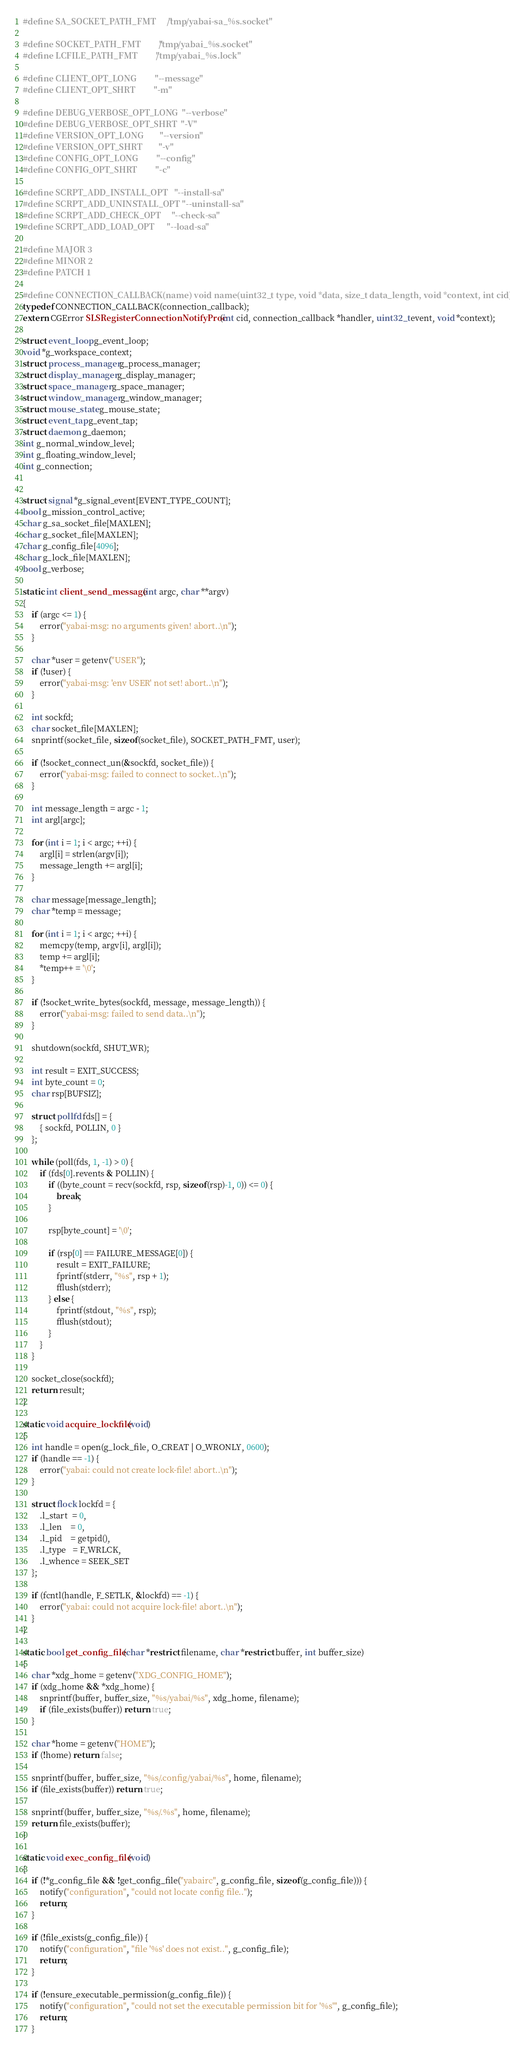<code> <loc_0><loc_0><loc_500><loc_500><_C_>#define SA_SOCKET_PATH_FMT      "/tmp/yabai-sa_%s.socket"

#define SOCKET_PATH_FMT         "/tmp/yabai_%s.socket"
#define LCFILE_PATH_FMT         "/tmp/yabai_%s.lock"

#define CLIENT_OPT_LONG         "--message"
#define CLIENT_OPT_SHRT         "-m"

#define DEBUG_VERBOSE_OPT_LONG  "--verbose"
#define DEBUG_VERBOSE_OPT_SHRT  "-V"
#define VERSION_OPT_LONG        "--version"
#define VERSION_OPT_SHRT        "-v"
#define CONFIG_OPT_LONG         "--config"
#define CONFIG_OPT_SHRT         "-c"

#define SCRPT_ADD_INSTALL_OPT   "--install-sa"
#define SCRPT_ADD_UNINSTALL_OPT "--uninstall-sa"
#define SCRPT_ADD_CHECK_OPT     "--check-sa"
#define SCRPT_ADD_LOAD_OPT      "--load-sa"

#define MAJOR 3
#define MINOR 2
#define PATCH 1

#define CONNECTION_CALLBACK(name) void name(uint32_t type, void *data, size_t data_length, void *context, int cid)
typedef CONNECTION_CALLBACK(connection_callback);
extern CGError SLSRegisterConnectionNotifyProc(int cid, connection_callback *handler, uint32_t event, void *context);

struct event_loop g_event_loop;
void *g_workspace_context;
struct process_manager g_process_manager;
struct display_manager g_display_manager;
struct space_manager g_space_manager;
struct window_manager g_window_manager;
struct mouse_state g_mouse_state;
struct event_tap g_event_tap;
struct daemon g_daemon;
int g_normal_window_level;
int g_floating_window_level;
int g_connection;


struct signal *g_signal_event[EVENT_TYPE_COUNT];
bool g_mission_control_active;
char g_sa_socket_file[MAXLEN];
char g_socket_file[MAXLEN];
char g_config_file[4096];
char g_lock_file[MAXLEN];
bool g_verbose;

static int client_send_message(int argc, char **argv)
{
    if (argc <= 1) {
        error("yabai-msg: no arguments given! abort..\n");
    }

    char *user = getenv("USER");
    if (!user) {
        error("yabai-msg: 'env USER' not set! abort..\n");
    }

    int sockfd;
    char socket_file[MAXLEN];
    snprintf(socket_file, sizeof(socket_file), SOCKET_PATH_FMT, user);

    if (!socket_connect_un(&sockfd, socket_file)) {
        error("yabai-msg: failed to connect to socket..\n");
    }

    int message_length = argc - 1;
    int argl[argc];

    for (int i = 1; i < argc; ++i) {
        argl[i] = strlen(argv[i]);
        message_length += argl[i];
    }

    char message[message_length];
    char *temp = message;

    for (int i = 1; i < argc; ++i) {
        memcpy(temp, argv[i], argl[i]);
        temp += argl[i];
        *temp++ = '\0';
    }

    if (!socket_write_bytes(sockfd, message, message_length)) {
        error("yabai-msg: failed to send data..\n");
    }

    shutdown(sockfd, SHUT_WR);

    int result = EXIT_SUCCESS;
    int byte_count = 0;
    char rsp[BUFSIZ];

    struct pollfd fds[] = {
        { sockfd, POLLIN, 0 }
    };

    while (poll(fds, 1, -1) > 0) {
        if (fds[0].revents & POLLIN) {
            if ((byte_count = recv(sockfd, rsp, sizeof(rsp)-1, 0)) <= 0) {
                break;
            }

            rsp[byte_count] = '\0';

            if (rsp[0] == FAILURE_MESSAGE[0]) {
                result = EXIT_FAILURE;
                fprintf(stderr, "%s", rsp + 1);
                fflush(stderr);
            } else {
                fprintf(stdout, "%s", rsp);
                fflush(stdout);
            }
        }
    }

    socket_close(sockfd);
    return result;
}

static void acquire_lockfile(void)
{
    int handle = open(g_lock_file, O_CREAT | O_WRONLY, 0600);
    if (handle == -1) {
        error("yabai: could not create lock-file! abort..\n");
    }

    struct flock lockfd = {
        .l_start  = 0,
        .l_len    = 0,
        .l_pid    = getpid(),
        .l_type   = F_WRLCK,
        .l_whence = SEEK_SET
    };

    if (fcntl(handle, F_SETLK, &lockfd) == -1) {
        error("yabai: could not acquire lock-file! abort..\n");
    }
}

static bool get_config_file(char *restrict filename, char *restrict buffer, int buffer_size)
{
    char *xdg_home = getenv("XDG_CONFIG_HOME");
    if (xdg_home && *xdg_home) {
        snprintf(buffer, buffer_size, "%s/yabai/%s", xdg_home, filename);
        if (file_exists(buffer)) return true;
    }

    char *home = getenv("HOME");
    if (!home) return false;

    snprintf(buffer, buffer_size, "%s/.config/yabai/%s", home, filename);
    if (file_exists(buffer)) return true;

    snprintf(buffer, buffer_size, "%s/.%s", home, filename);
    return file_exists(buffer);
}

static void exec_config_file(void)
{
    if (!*g_config_file && !get_config_file("yabairc", g_config_file, sizeof(g_config_file))) {
        notify("configuration", "could not locate config file..");
        return;
    }

    if (!file_exists(g_config_file)) {
        notify("configuration", "file '%s' does not exist..", g_config_file);
        return;
    }

    if (!ensure_executable_permission(g_config_file)) {
        notify("configuration", "could not set the executable permission bit for '%s'", g_config_file);
        return;
    }
</code> 